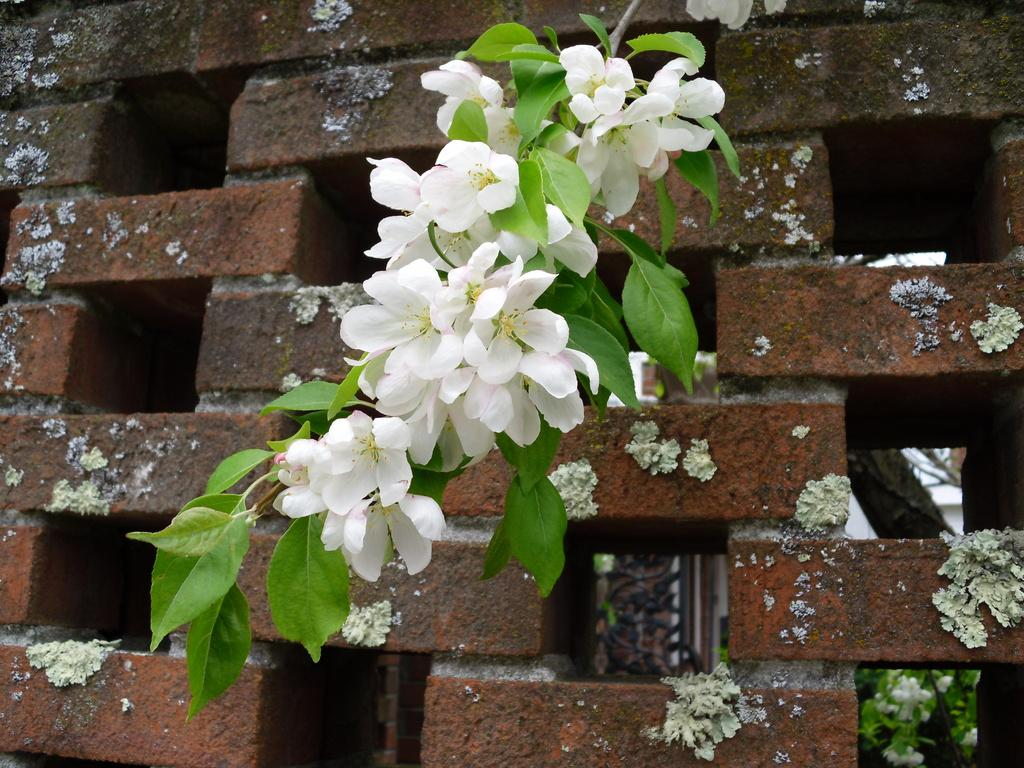What type of plants can be seen in the image? There are flowers in the image. What part of the flowers is visible in the image? There are leaves on the stem in the image. What can be seen in the background of the image? There is a wall in the background of the image. How do the flowers control the news in the image? There are no flowers or news present in the image, so this question cannot be answered. 